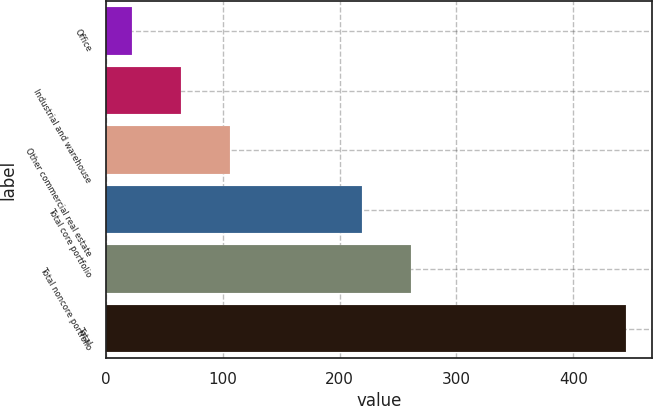Convert chart to OTSL. <chart><loc_0><loc_0><loc_500><loc_500><bar_chart><fcel>Office<fcel>Industrial and warehouse<fcel>Other commercial real estate<fcel>Total core portfolio<fcel>Total noncore portfolio<fcel>Total<nl><fcel>22<fcel>64.3<fcel>106.6<fcel>219<fcel>261.3<fcel>445<nl></chart> 